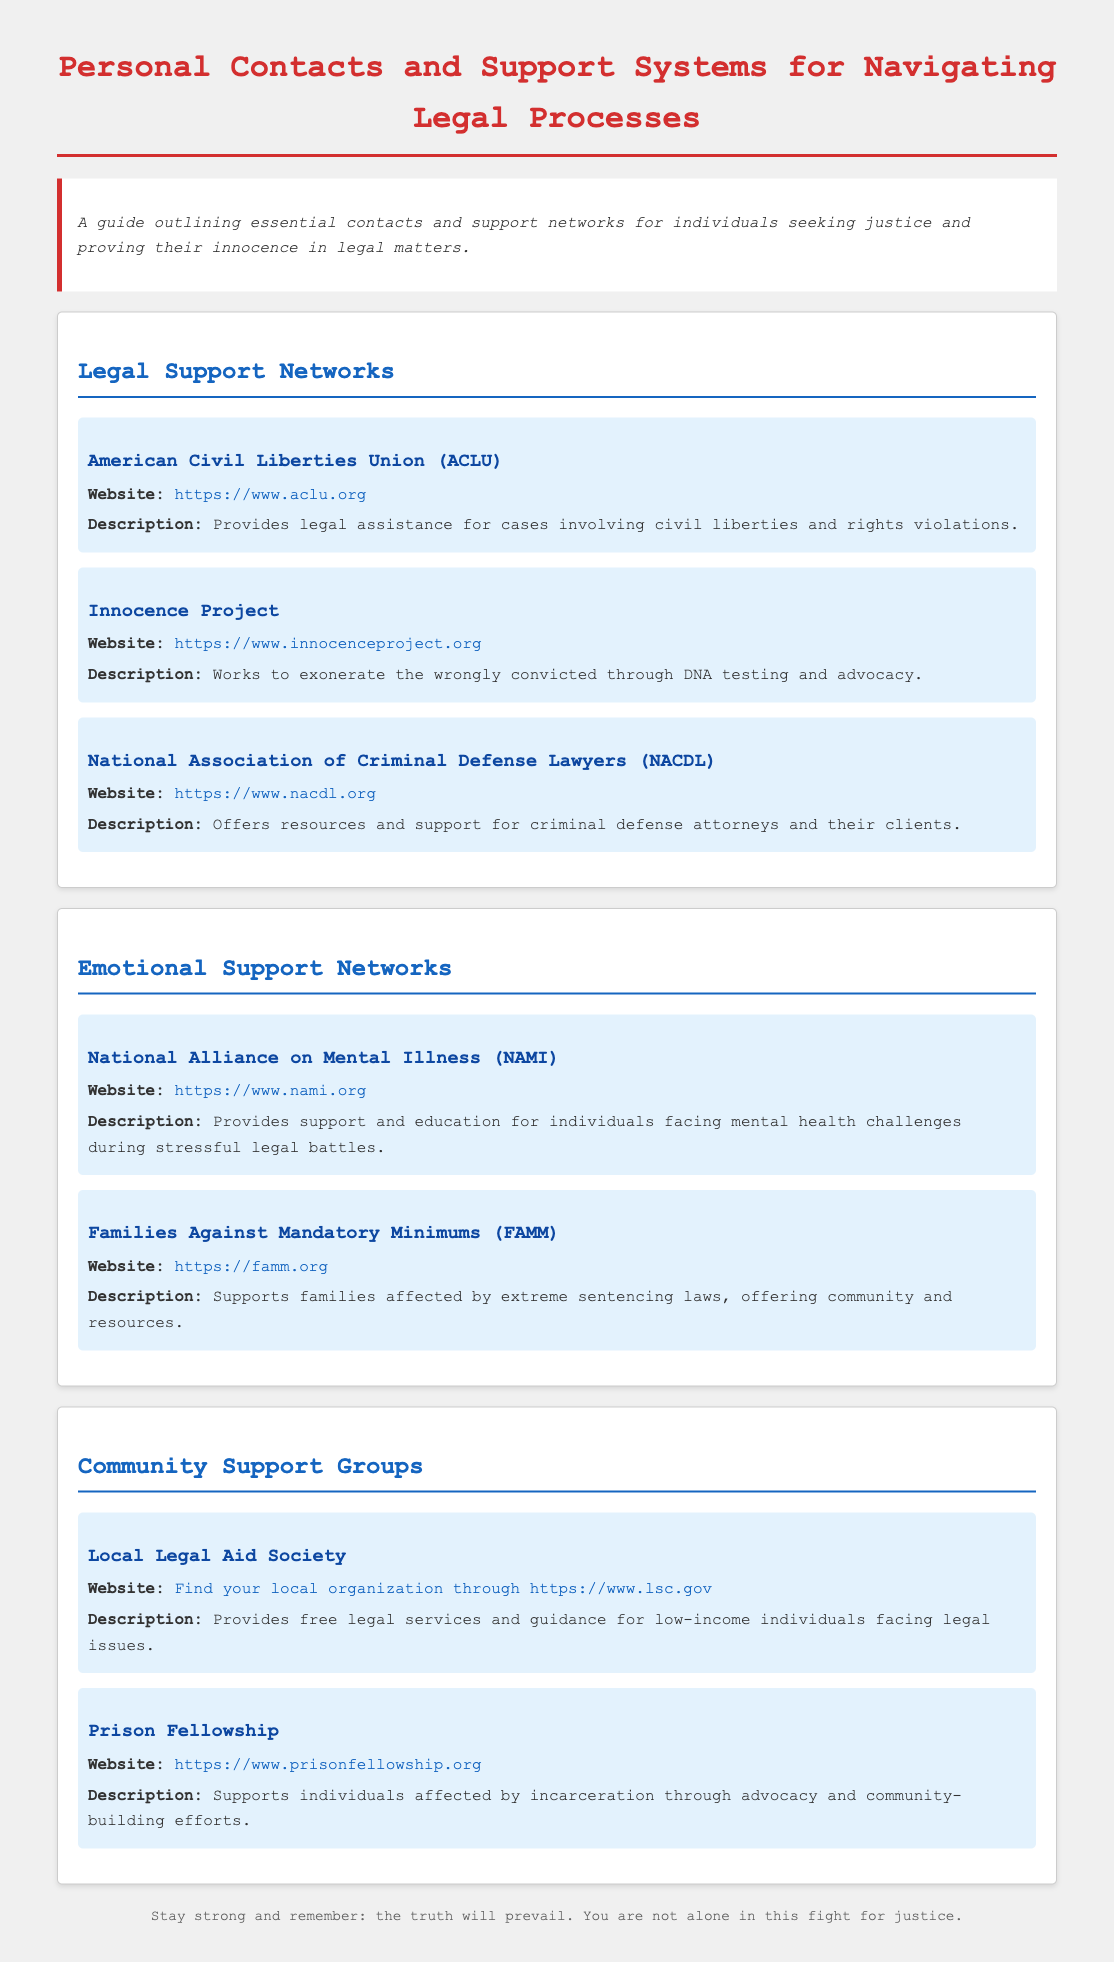What organization provides legal assistance for civil liberties cases? The document lists the ACLU as an organization that provides legal assistance for civil liberties cases.
Answer: ACLU Which project works to exonerate the wrongly convicted through DNA testing? The Innocence Project is identified as the organization working to exonerate the wrongly convicted through DNA testing.
Answer: Innocence Project What does NAMI stand for? The document describes NAMI as the National Alliance on Mental Illness.
Answer: National Alliance on Mental Illness What type of support does Families Against Mandatory Minimums provide? FAMM offers support to families affected by extreme sentencing laws, as described in the document.
Answer: Support for families How many legal support networks are listed in the document? The document lists three legal support networks overall under the category.
Answer: Three What is the website for the local legal aid society? The document provides a link to find local organizations through the website at LSC.
Answer: https://www.lsc.gov Which organization offers community-building efforts for those affected by incarceration? The document details Prison Fellowship as the organization that supports individuals affected by incarceration through advocacy and community-building.
Answer: Prison Fellowship Which organization provides emotional support during stressful legal battles? NAMI is indicated in the document as providing emotional support and education for individuals facing mental health challenges during legal battles.
Answer: NAMI 